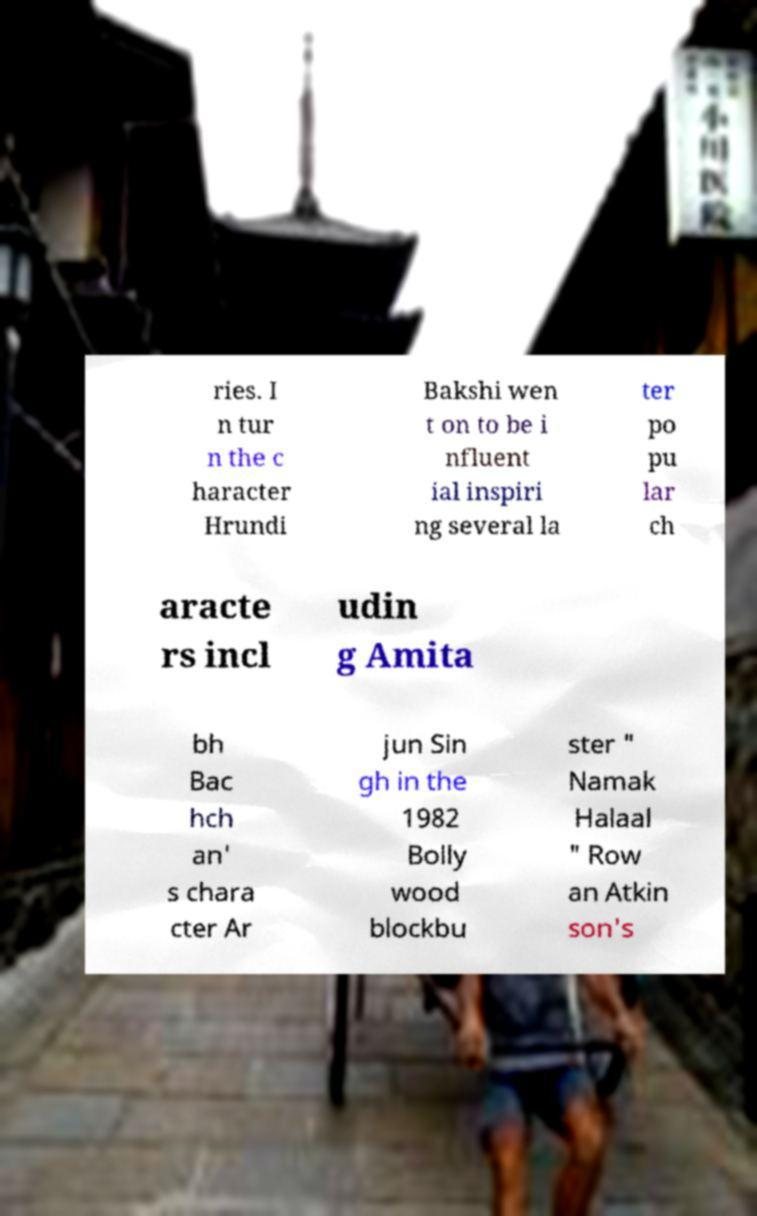What messages or text are displayed in this image? I need them in a readable, typed format. ries. I n tur n the c haracter Hrundi Bakshi wen t on to be i nfluent ial inspiri ng several la ter po pu lar ch aracte rs incl udin g Amita bh Bac hch an' s chara cter Ar jun Sin gh in the 1982 Bolly wood blockbu ster " Namak Halaal " Row an Atkin son's 